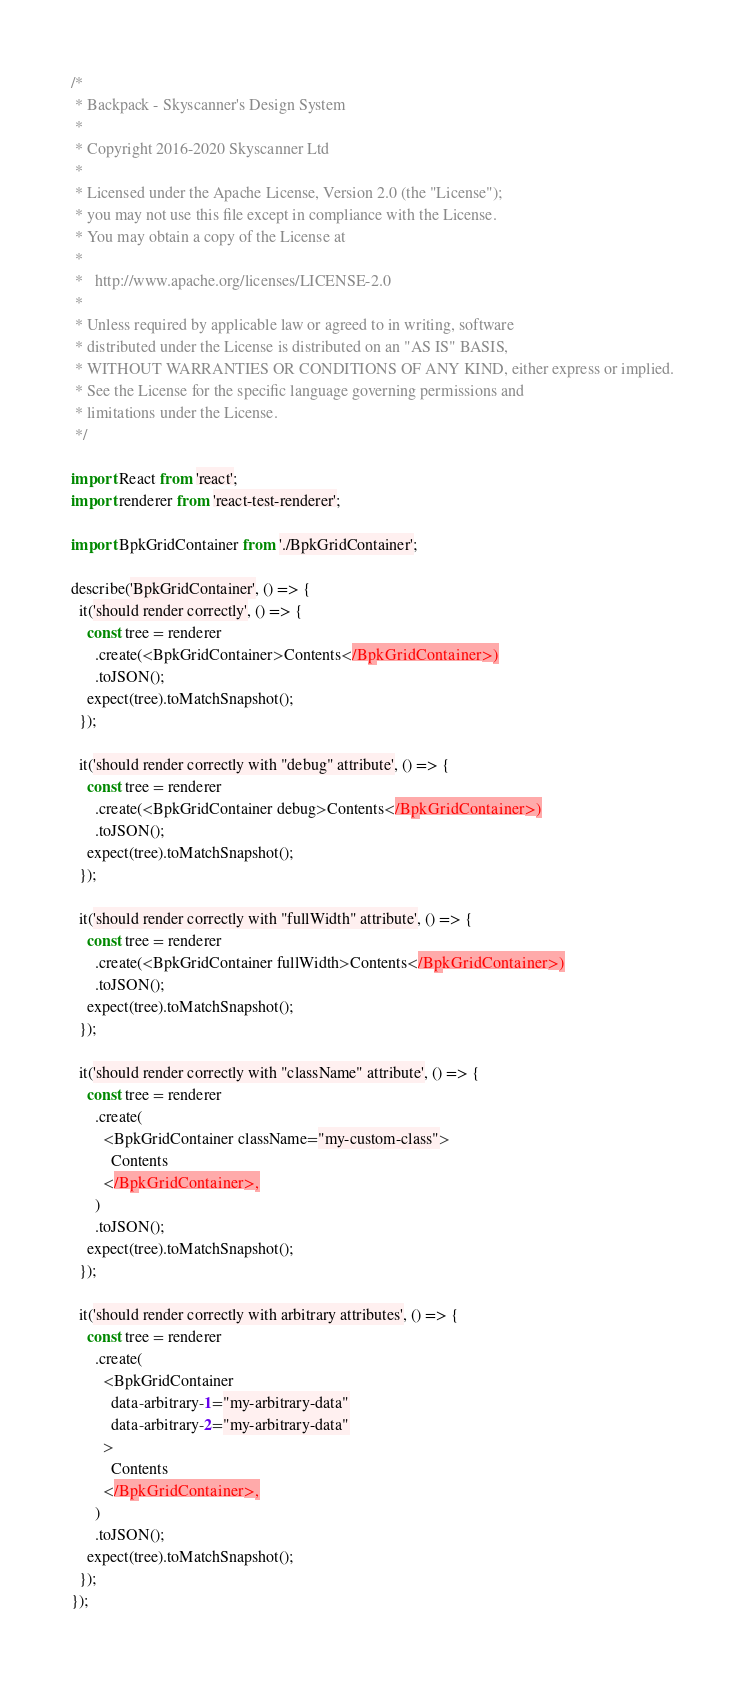Convert code to text. <code><loc_0><loc_0><loc_500><loc_500><_JavaScript_>/*
 * Backpack - Skyscanner's Design System
 *
 * Copyright 2016-2020 Skyscanner Ltd
 *
 * Licensed under the Apache License, Version 2.0 (the "License");
 * you may not use this file except in compliance with the License.
 * You may obtain a copy of the License at
 *
 *   http://www.apache.org/licenses/LICENSE-2.0
 *
 * Unless required by applicable law or agreed to in writing, software
 * distributed under the License is distributed on an "AS IS" BASIS,
 * WITHOUT WARRANTIES OR CONDITIONS OF ANY KIND, either express or implied.
 * See the License for the specific language governing permissions and
 * limitations under the License.
 */

import React from 'react';
import renderer from 'react-test-renderer';

import BpkGridContainer from './BpkGridContainer';

describe('BpkGridContainer', () => {
  it('should render correctly', () => {
    const tree = renderer
      .create(<BpkGridContainer>Contents</BpkGridContainer>)
      .toJSON();
    expect(tree).toMatchSnapshot();
  });

  it('should render correctly with "debug" attribute', () => {
    const tree = renderer
      .create(<BpkGridContainer debug>Contents</BpkGridContainer>)
      .toJSON();
    expect(tree).toMatchSnapshot();
  });

  it('should render correctly with "fullWidth" attribute', () => {
    const tree = renderer
      .create(<BpkGridContainer fullWidth>Contents</BpkGridContainer>)
      .toJSON();
    expect(tree).toMatchSnapshot();
  });

  it('should render correctly with "className" attribute', () => {
    const tree = renderer
      .create(
        <BpkGridContainer className="my-custom-class">
          Contents
        </BpkGridContainer>,
      )
      .toJSON();
    expect(tree).toMatchSnapshot();
  });

  it('should render correctly with arbitrary attributes', () => {
    const tree = renderer
      .create(
        <BpkGridContainer
          data-arbitrary-1="my-arbitrary-data"
          data-arbitrary-2="my-arbitrary-data"
        >
          Contents
        </BpkGridContainer>,
      )
      .toJSON();
    expect(tree).toMatchSnapshot();
  });
});
</code> 